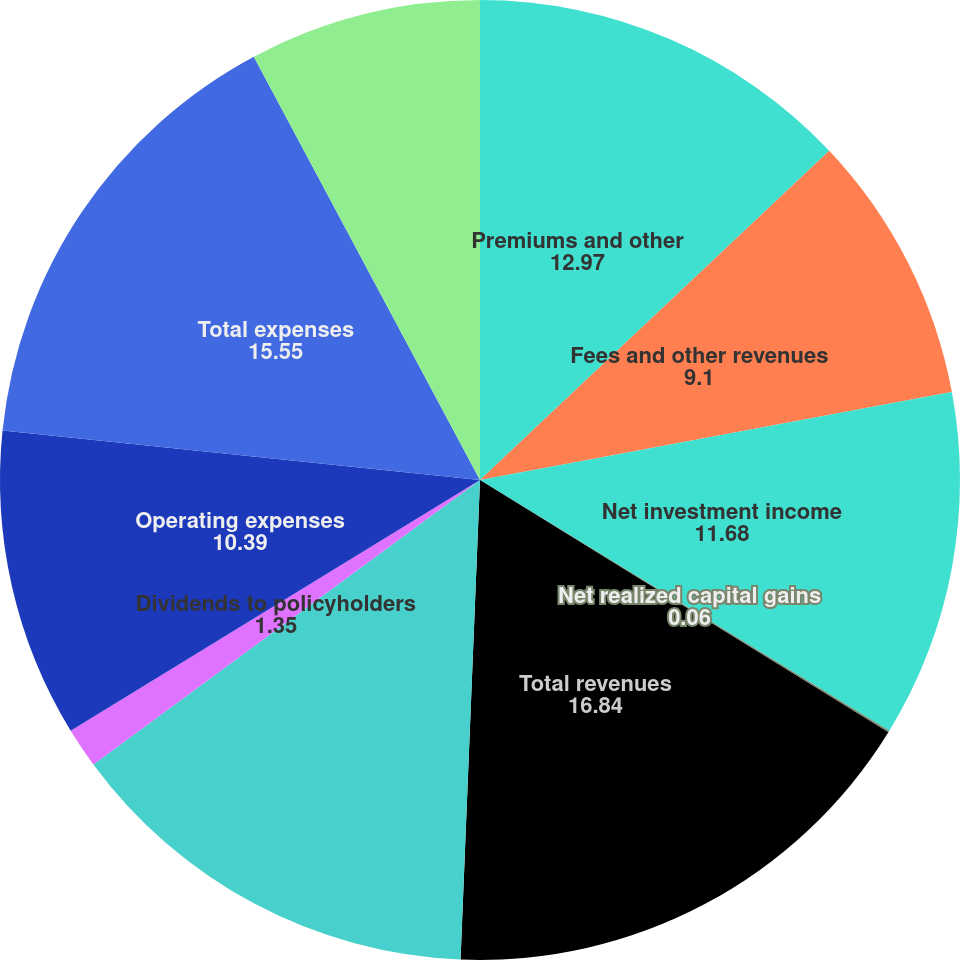Convert chart. <chart><loc_0><loc_0><loc_500><loc_500><pie_chart><fcel>Premiums and other<fcel>Fees and other revenues<fcel>Net investment income<fcel>Net realized capital gains<fcel>Total revenues<fcel>Benefits claims and settlement<fcel>Dividends to policyholders<fcel>Operating expenses<fcel>Total expenses<fcel>Income from continuing<nl><fcel>12.97%<fcel>9.1%<fcel>11.68%<fcel>0.06%<fcel>16.84%<fcel>14.26%<fcel>1.35%<fcel>10.39%<fcel>15.55%<fcel>7.81%<nl></chart> 